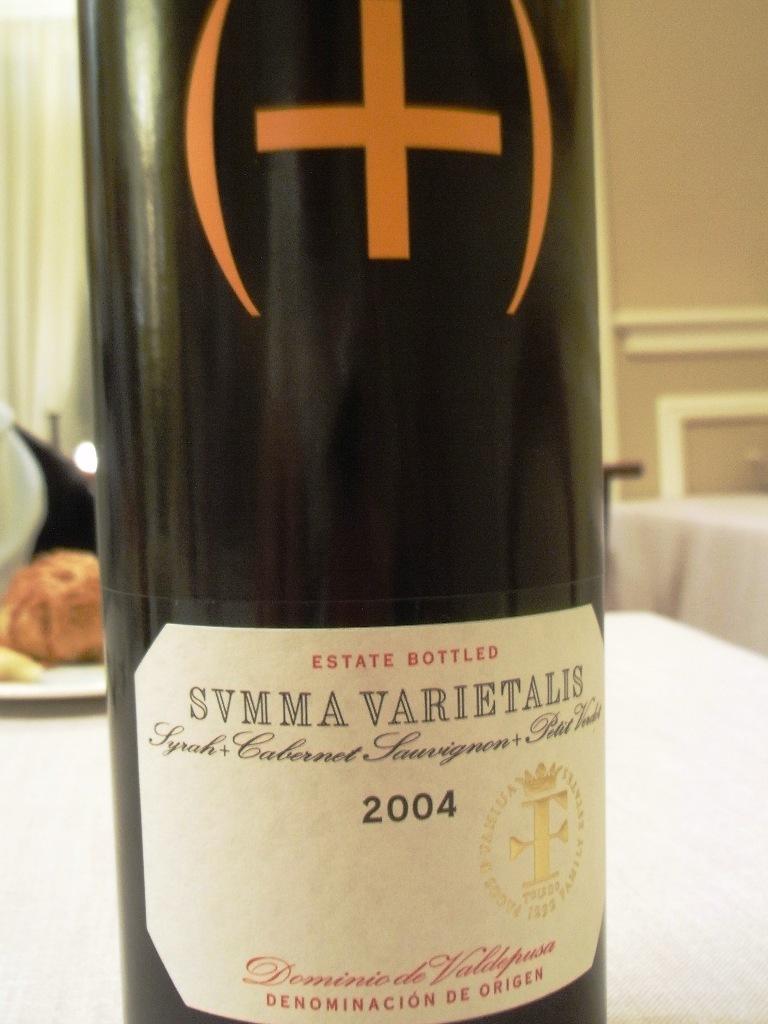When was this wine made?
Give a very brief answer. 2004. What kind of "bottled" is this?
Make the answer very short. Estate. 